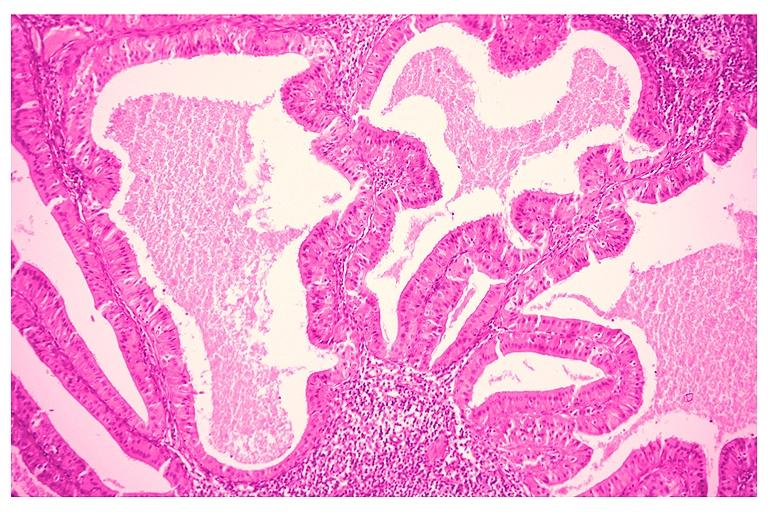where is this?
Answer the question using a single word or phrase. Oral 